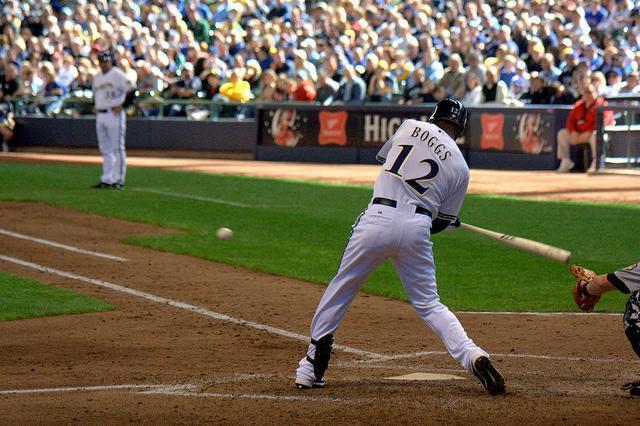How many people are in the picture?
Give a very brief answer. 4. 